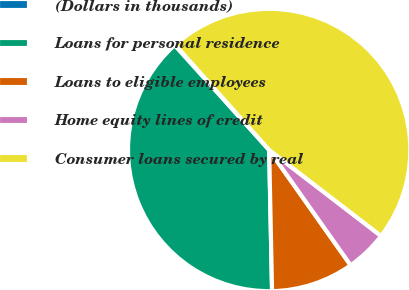Convert chart. <chart><loc_0><loc_0><loc_500><loc_500><pie_chart><fcel>(Dollars in thousands)<fcel>Loans for personal residence<fcel>Loans to eligible employees<fcel>Home equity lines of credit<fcel>Consumer loans secured by real<nl><fcel>0.08%<fcel>38.64%<fcel>9.47%<fcel>4.78%<fcel>47.03%<nl></chart> 